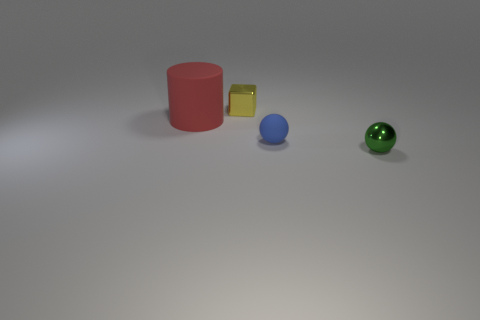Add 3 small blue matte things. How many objects exist? 7 Subtract all blue balls. How many balls are left? 1 Subtract 0 red cubes. How many objects are left? 4 Subtract all cubes. How many objects are left? 3 Subtract all cyan cylinders. Subtract all cyan balls. How many cylinders are left? 1 Subtract all tiny green blocks. Subtract all big red rubber cylinders. How many objects are left? 3 Add 4 shiny things. How many shiny things are left? 6 Add 1 big yellow rubber spheres. How many big yellow rubber spheres exist? 1 